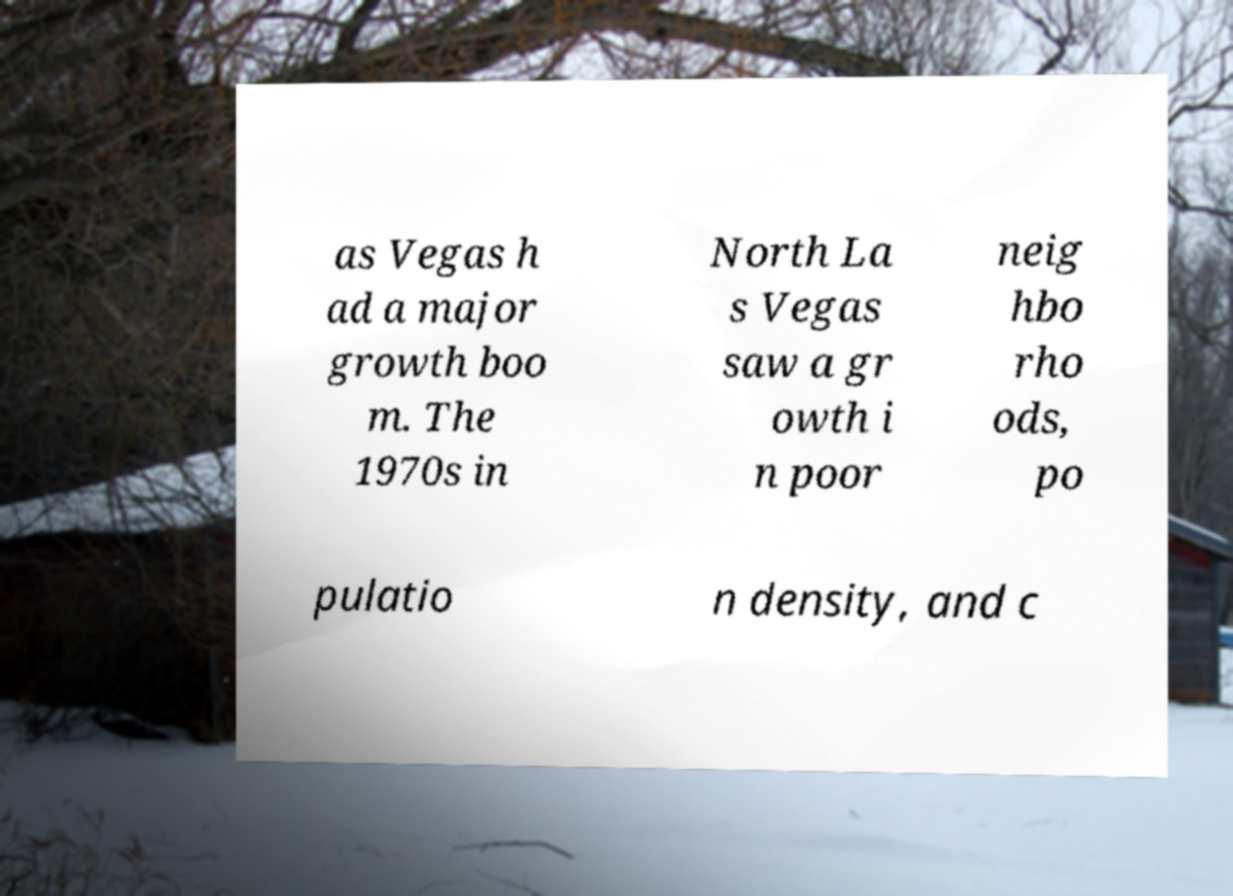Could you extract and type out the text from this image? as Vegas h ad a major growth boo m. The 1970s in North La s Vegas saw a gr owth i n poor neig hbo rho ods, po pulatio n density, and c 